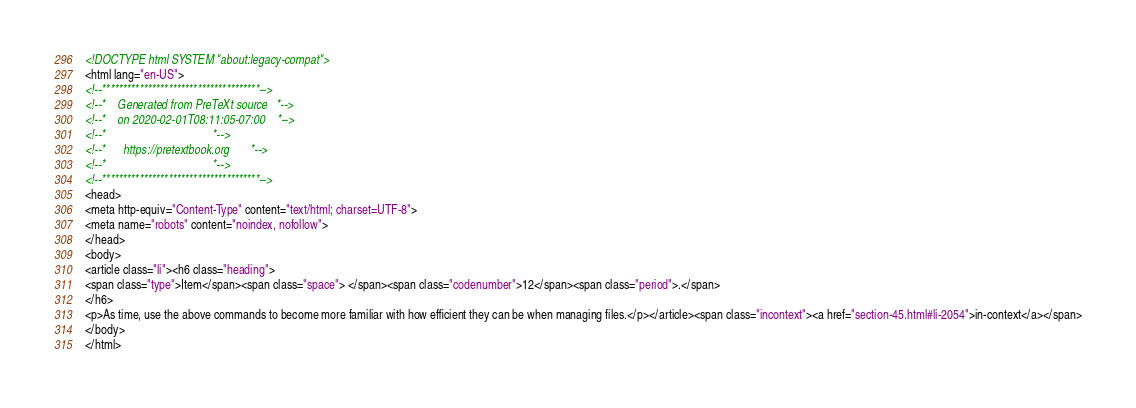<code> <loc_0><loc_0><loc_500><loc_500><_HTML_><!DOCTYPE html SYSTEM "about:legacy-compat">
<html lang="en-US">
<!--**************************************-->
<!--*    Generated from PreTeXt source   *-->
<!--*    on 2020-02-01T08:11:05-07:00    *-->
<!--*                                    *-->
<!--*      https://pretextbook.org       *-->
<!--*                                    *-->
<!--**************************************-->
<head>
<meta http-equiv="Content-Type" content="text/html; charset=UTF-8">
<meta name="robots" content="noindex, nofollow">
</head>
<body>
<article class="li"><h6 class="heading">
<span class="type">Item</span><span class="space"> </span><span class="codenumber">12</span><span class="period">.</span>
</h6>
<p>As time, use the above commands to become more familiar with how efficient they can be when managing files.</p></article><span class="incontext"><a href="section-45.html#li-2054">in-context</a></span>
</body>
</html>
</code> 